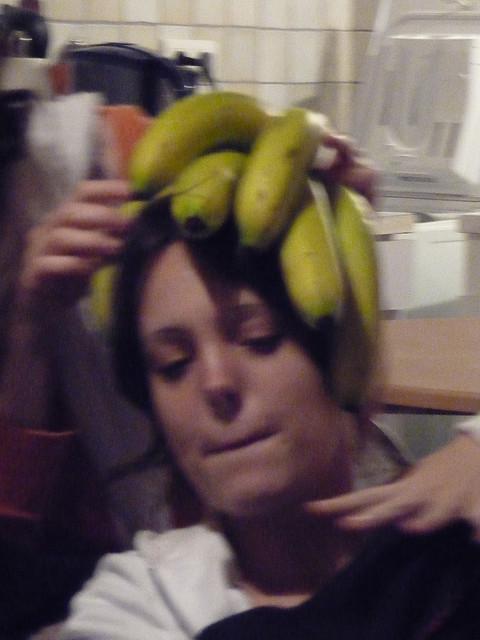What is the woman wearing on her head?
Write a very short answer. Bananas. Does the fruit appear to be ripe?
Quick response, please. Yes. Are the bananas part of her head?
Keep it brief. No. Is that a lot of bananas?
Concise answer only. Yes. Would this be a LinkedIn profile picture?
Write a very short answer. No. Are the bananas ripe?
Concise answer only. Yes. What is on the woman's head?
Answer briefly. Bananas. Is  man or female holding the dog?
Be succinct. Female. 